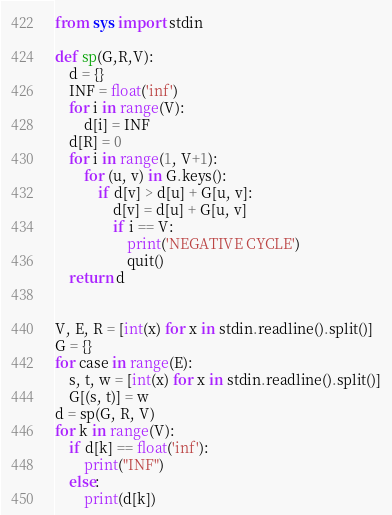<code> <loc_0><loc_0><loc_500><loc_500><_Python_>from sys import stdin

def sp(G,R,V):
    d = {}
    INF = float('inf')
    for i in range(V):
        d[i] = INF
    d[R] = 0
    for i in range(1, V+1):
        for (u, v) in G.keys():
            if d[v] > d[u] + G[u, v]:
                d[v] = d[u] + G[u, v]
                if i == V:
                    print('NEGATIVE CYCLE')
                    quit()
    return d


V, E, R = [int(x) for x in stdin.readline().split()]
G = {}
for case in range(E):
    s, t, w = [int(x) for x in stdin.readline().split()]
    G[(s, t)] = w
d = sp(G, R, V)
for k in range(V):
    if d[k] == float('inf'):
        print("INF")
    else:
        print(d[k])</code> 